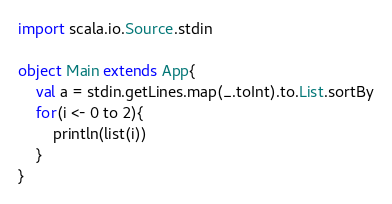<code> <loc_0><loc_0><loc_500><loc_500><_Scala_>import scala.io.Source.stdin

object Main extends App{
	val a = stdin.getLines.map(_.toInt).to.List.sortBy
	for(i <- 0 to 2){
		println(list(i))
	}
}</code> 